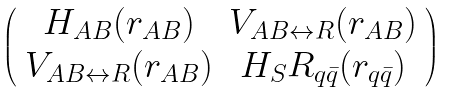Convert formula to latex. <formula><loc_0><loc_0><loc_500><loc_500>\left ( \begin{array} { c c } H _ { A B } ( r _ { A B } ) & V _ { A B \leftrightarrow R } ( r _ { A B } ) \\ V _ { A B \leftrightarrow R } ( r _ { A B } ) & H _ { S } { R _ { q \bar { q } } } ( r _ { q \bar { q } } ) \end{array} \right )</formula> 